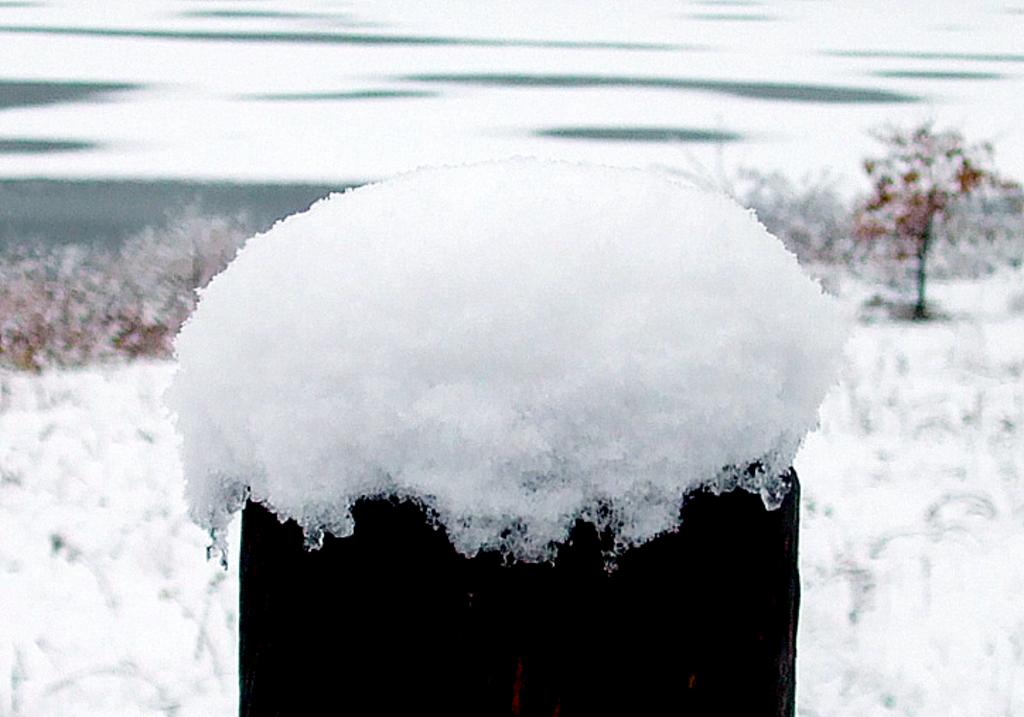What is present at the bottom of the image? There is snow at the bottom of the image. What can be seen in the distance in the image? There are trees in the background of the image. How would you describe the appearance of the background? The background appears blurry. What is the income of the trees in the image? There is no information about the income of the trees in the image, as trees do not have income. How many times does the image twist in a clockwise direction? The image does not twist; it is a still image. 